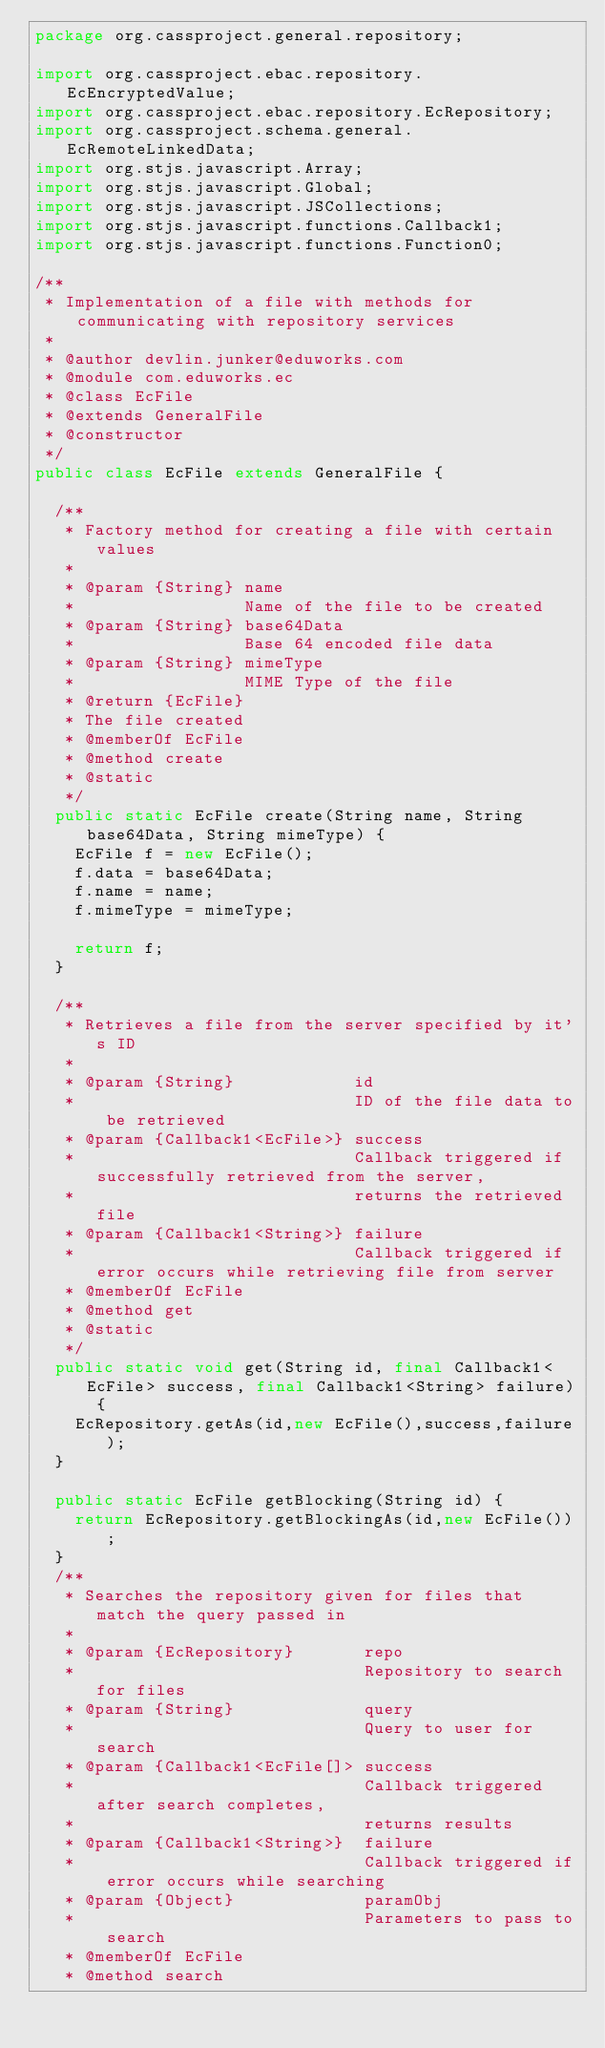Convert code to text. <code><loc_0><loc_0><loc_500><loc_500><_Java_>package org.cassproject.general.repository;

import org.cassproject.ebac.repository.EcEncryptedValue;
import org.cassproject.ebac.repository.EcRepository;
import org.cassproject.schema.general.EcRemoteLinkedData;
import org.stjs.javascript.Array;
import org.stjs.javascript.Global;
import org.stjs.javascript.JSCollections;
import org.stjs.javascript.functions.Callback1;
import org.stjs.javascript.functions.Function0;

/**
 * Implementation of a file with methods for communicating with repository services
 *
 * @author devlin.junker@eduworks.com
 * @module com.eduworks.ec
 * @class EcFile
 * @extends GeneralFile
 * @constructor
 */
public class EcFile extends GeneralFile {

	/**
	 * Factory method for creating a file with certain values
	 *
	 * @param {String} name
	 *                 Name of the file to be created
	 * @param {String} base64Data
	 *                 Base 64 encoded file data
	 * @param {String} mimeType
	 *                 MIME Type of the file
	 * @return {EcFile}
	 * The file created
	 * @memberOf EcFile
	 * @method create
	 * @static
	 */
	public static EcFile create(String name, String base64Data, String mimeType) {
		EcFile f = new EcFile();
		f.data = base64Data;
		f.name = name;
		f.mimeType = mimeType;

		return f;
	}

	/**
	 * Retrieves a file from the server specified by it's ID
	 *
	 * @param {String}            id
	 *                            ID of the file data to be retrieved
	 * @param {Callback1<EcFile>} success
	 *                            Callback triggered if successfully retrieved from the server,
	 *                            returns the retrieved file
	 * @param {Callback1<String>} failure
	 *                            Callback triggered if error occurs while retrieving file from server
	 * @memberOf EcFile
	 * @method get
	 * @static
	 */
	public static void get(String id, final Callback1<EcFile> success, final Callback1<String> failure) {
		EcRepository.getAs(id,new EcFile(),success,failure);
	}

	public static EcFile getBlocking(String id) {
		return EcRepository.getBlockingAs(id,new EcFile());
	}
	/**
	 * Searches the repository given for files that match the query passed in
	 *
	 * @param {EcRepository}       repo
	 *                             Repository to search for files
	 * @param {String}             query
	 *                             Query to user for search
	 * @param {Callback1<EcFile[]> success
	 *                             Callback triggered after search completes,
	 *                             returns results
	 * @param {Callback1<String>}  failure
	 *                             Callback triggered if error occurs while searching
	 * @param {Object}             paramObj
	 *                             Parameters to pass to search
	 * @memberOf EcFile
	 * @method search</code> 